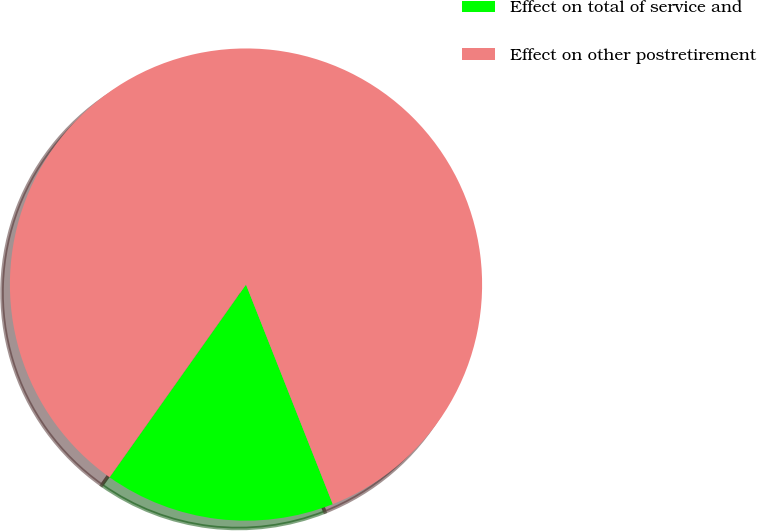Convert chart to OTSL. <chart><loc_0><loc_0><loc_500><loc_500><pie_chart><fcel>Effect on total of service and<fcel>Effect on other postretirement<nl><fcel>15.79%<fcel>84.21%<nl></chart> 